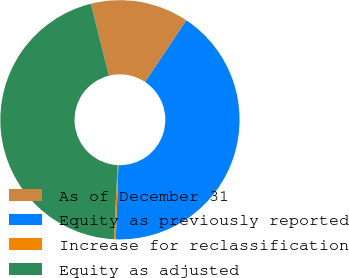Convert chart to OTSL. <chart><loc_0><loc_0><loc_500><loc_500><pie_chart><fcel>As of December 31<fcel>Equity as previously reported<fcel>Increase for reclassification<fcel>Equity as adjusted<nl><fcel>13.28%<fcel>41.17%<fcel>0.26%<fcel>45.29%<nl></chart> 